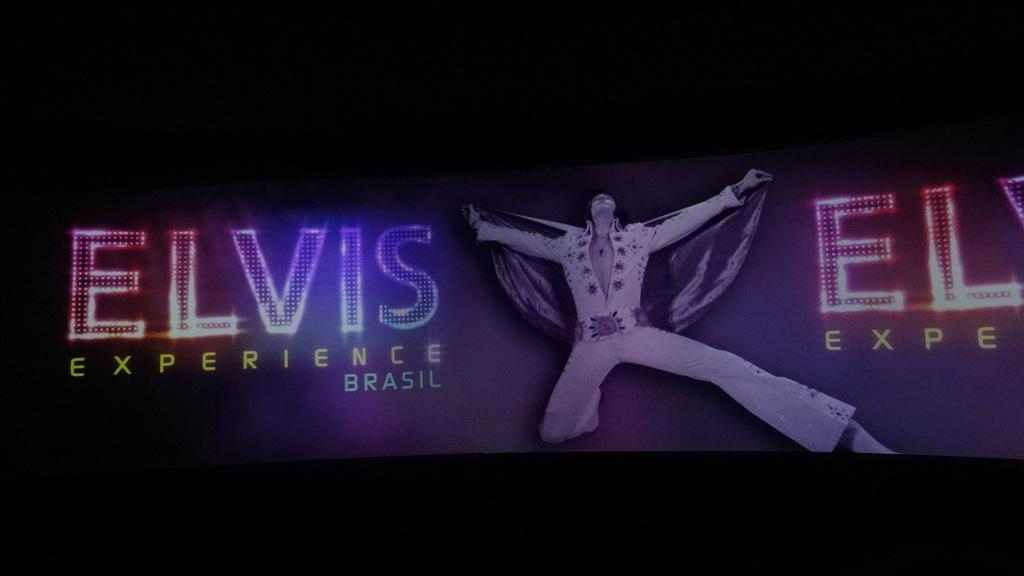What is present in the image? There is a man in the image. Can you describe any additional details about the image? There is writing on the image. What type of magic is the man performing in the image? There is no indication of magic or any magical activity in the image. 